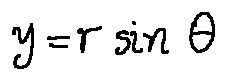Convert formula to latex. <formula><loc_0><loc_0><loc_500><loc_500>y = r \sin \theta</formula> 